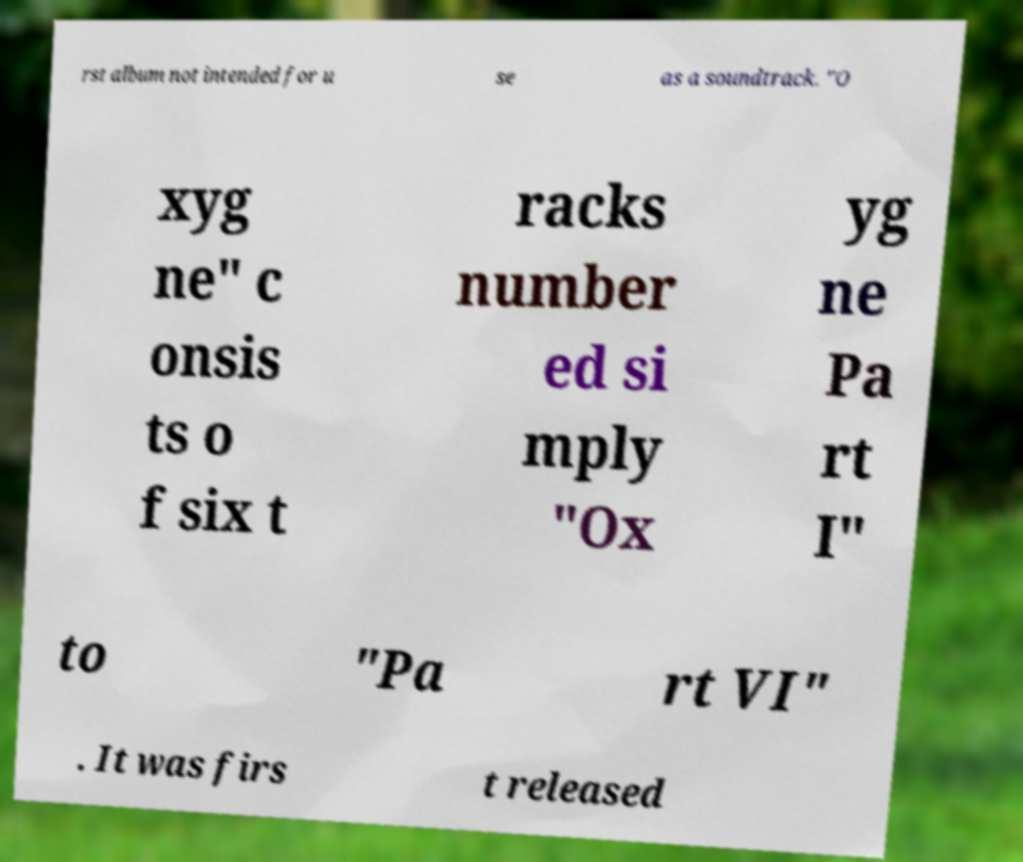Can you read and provide the text displayed in the image?This photo seems to have some interesting text. Can you extract and type it out for me? rst album not intended for u se as a soundtrack. "O xyg ne" c onsis ts o f six t racks number ed si mply "Ox yg ne Pa rt I" to "Pa rt VI" . It was firs t released 